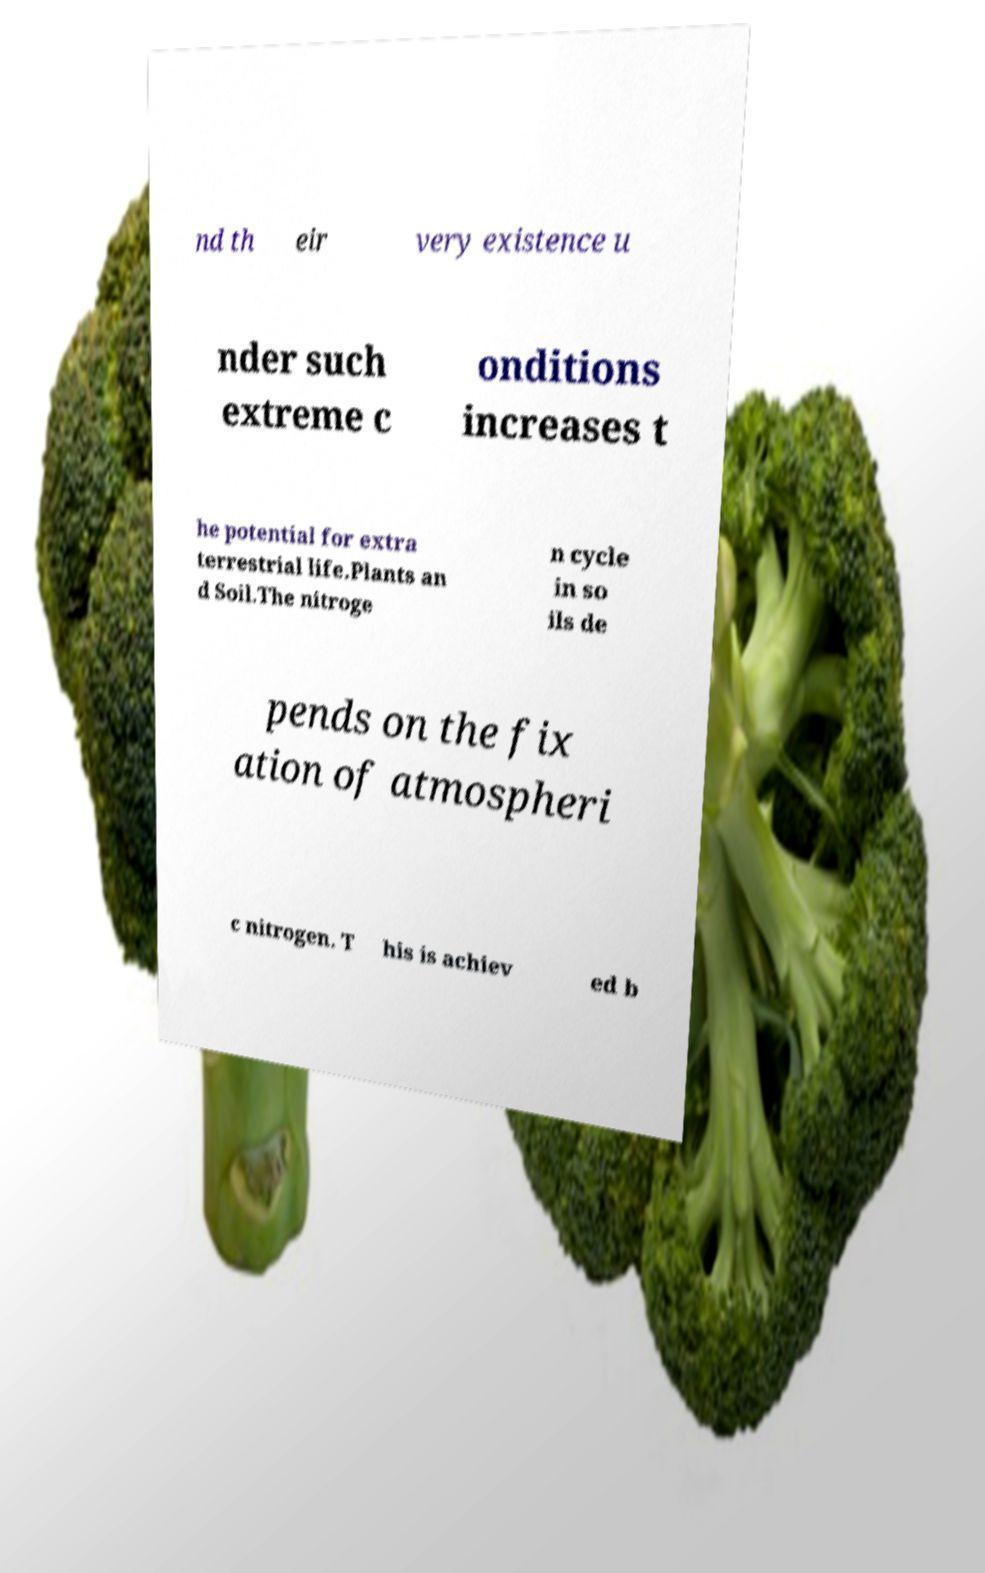There's text embedded in this image that I need extracted. Can you transcribe it verbatim? nd th eir very existence u nder such extreme c onditions increases t he potential for extra terrestrial life.Plants an d Soil.The nitroge n cycle in so ils de pends on the fix ation of atmospheri c nitrogen. T his is achiev ed b 